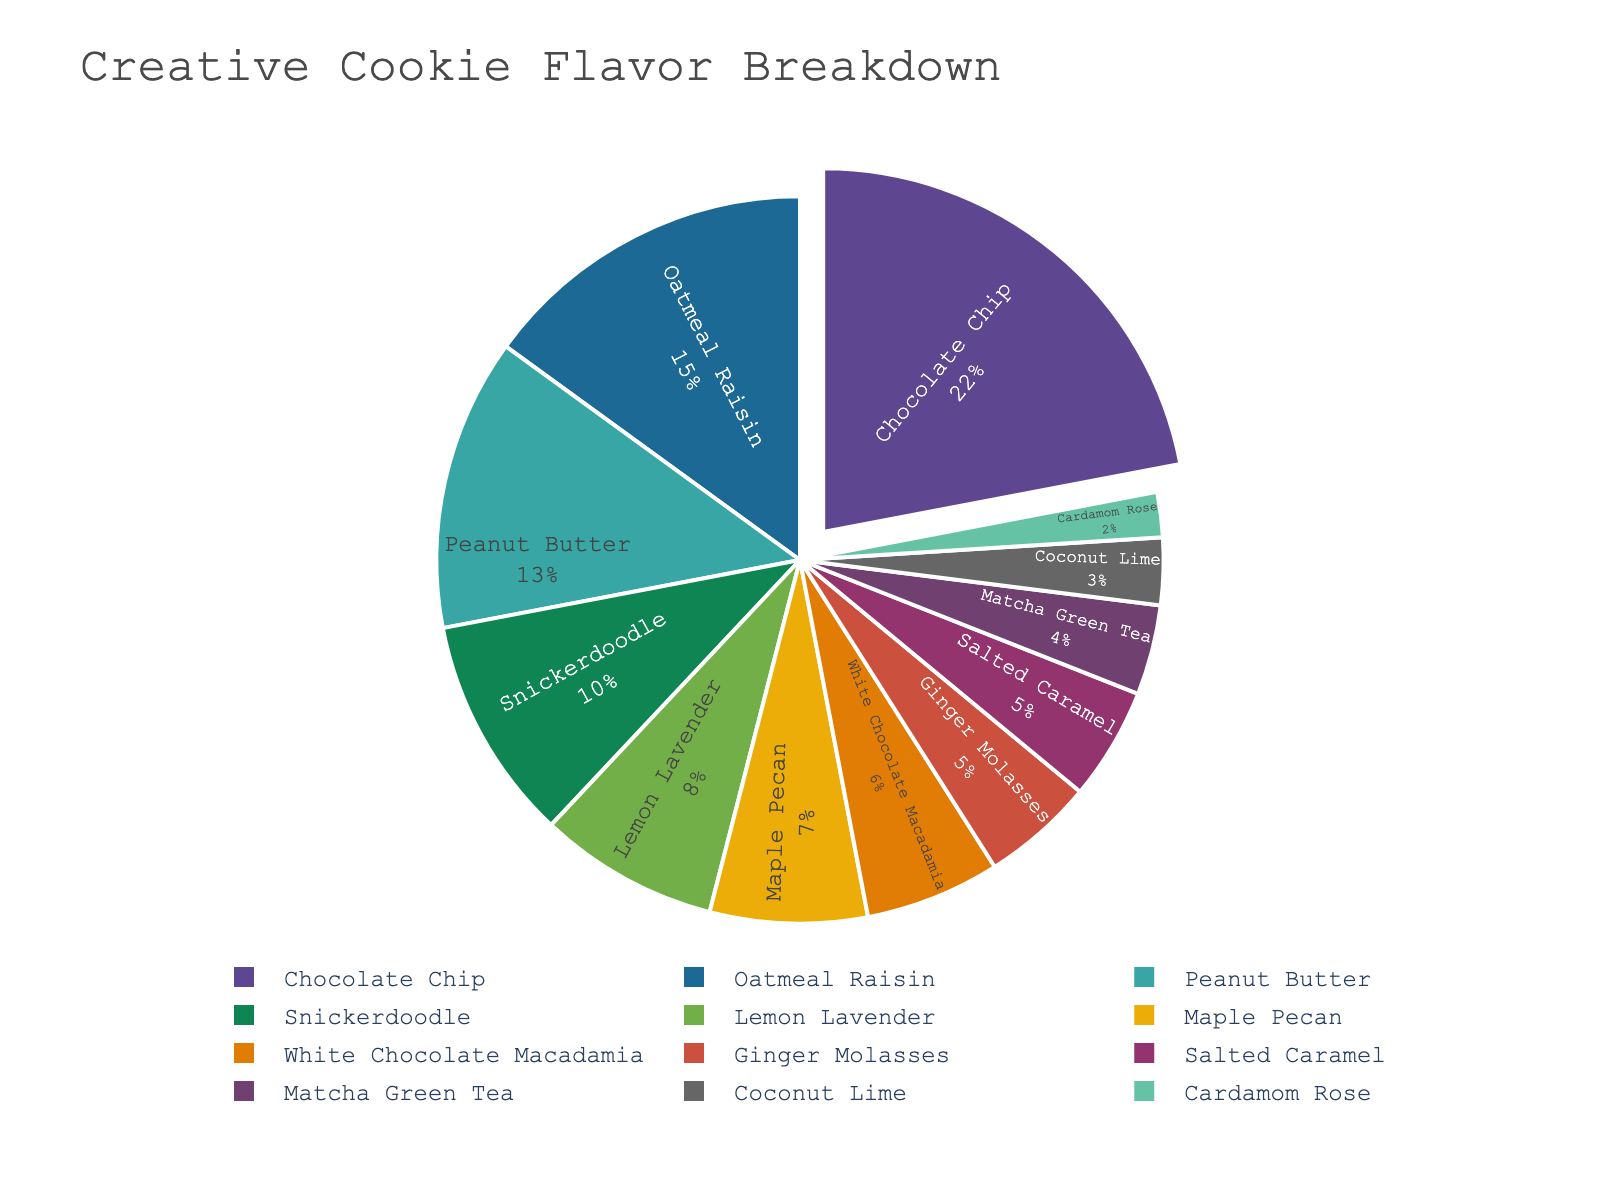Which cookie flavor is used the most in recipes? The largest section of the pie chart represents the flavor with the highest percentage. In this case, it is Chocolate Chip at 22%.
Answer: Chocolate Chip How does the usage percentage of Oatmeal Raisin compare to Snickerdoodle? Looking at the pie chart, Oatmeal Raisin is at 15%, while Snickerdoodle is at 10%. Thus, Oatmeal Raisin is used more frequently than Snickerdoodle.
Answer: Oatmeal Raisin > Snickerdoodle What is the combined percentage of the three least used cookie flavors? Identify the three flavors with the smallest sections: Coconut Lime (3%), Cardamom Rose (2%), and Matcha Green Tea (4%). Summing these gives 3% + 2% + 4% = 9%.
Answer: 9% Which cookie flavor is represented by a pull-out section of the pie chart? The flavor with the highest percentage is usually highlighted by a pull-out section. Here, it's Chocolate Chip, which has 22%.
Answer: Chocolate Chip What is the difference in usage percentage between Peanut Butter and White Chocolate Macadamia? Peanut Butter is at 13%, and White Chocolate Macadamia is at 6%. Subtract the smaller from the larger: 13% - 6% = 7%.
Answer: 7% Which flavor is used more frequently: Maple Pecan or Lemon Lavender? Maple Pecan has a usage percentage of 7%, while Lemon Lavender has 8%. Therefore, Lemon Lavender is used more frequently.
Answer: Lemon Lavender What percentage of recipes use either Salted Caramel or Ginger Molasses? The percentages for Salted Caramel and Ginger Molasses are both 5%. Summing these gives 5% + 5% = 10%.
Answer: 10% Is the percentage of Oatmeal Raisin more than double the percentage of Cardamom Rose? Oatmeal Raisin is at 15%, while Cardamom Rose is at 2%. Doubling Cardamom Rose’s percentage is 2% * 2 = 4%. Since 15% > 4%, the answer is yes.
Answer: Yes How does the percentage of flavors used in recipes break down? Visualize the entire pie chart and decompose the individual percentages for each flavor. They range from Chocolate Chip at 22% to Cardamom Rose at 2%.
Answer: Various percentages What's the total percentage of all other flavors except for the top three most used flavors? The top three flavors are Chocolate Chip (22%), Oatmeal Raisin (15%), and Peanut Butter (13%), summing to 50%. Subtract this from 100%: 100% - 50% = 50%.
Answer: 50% 